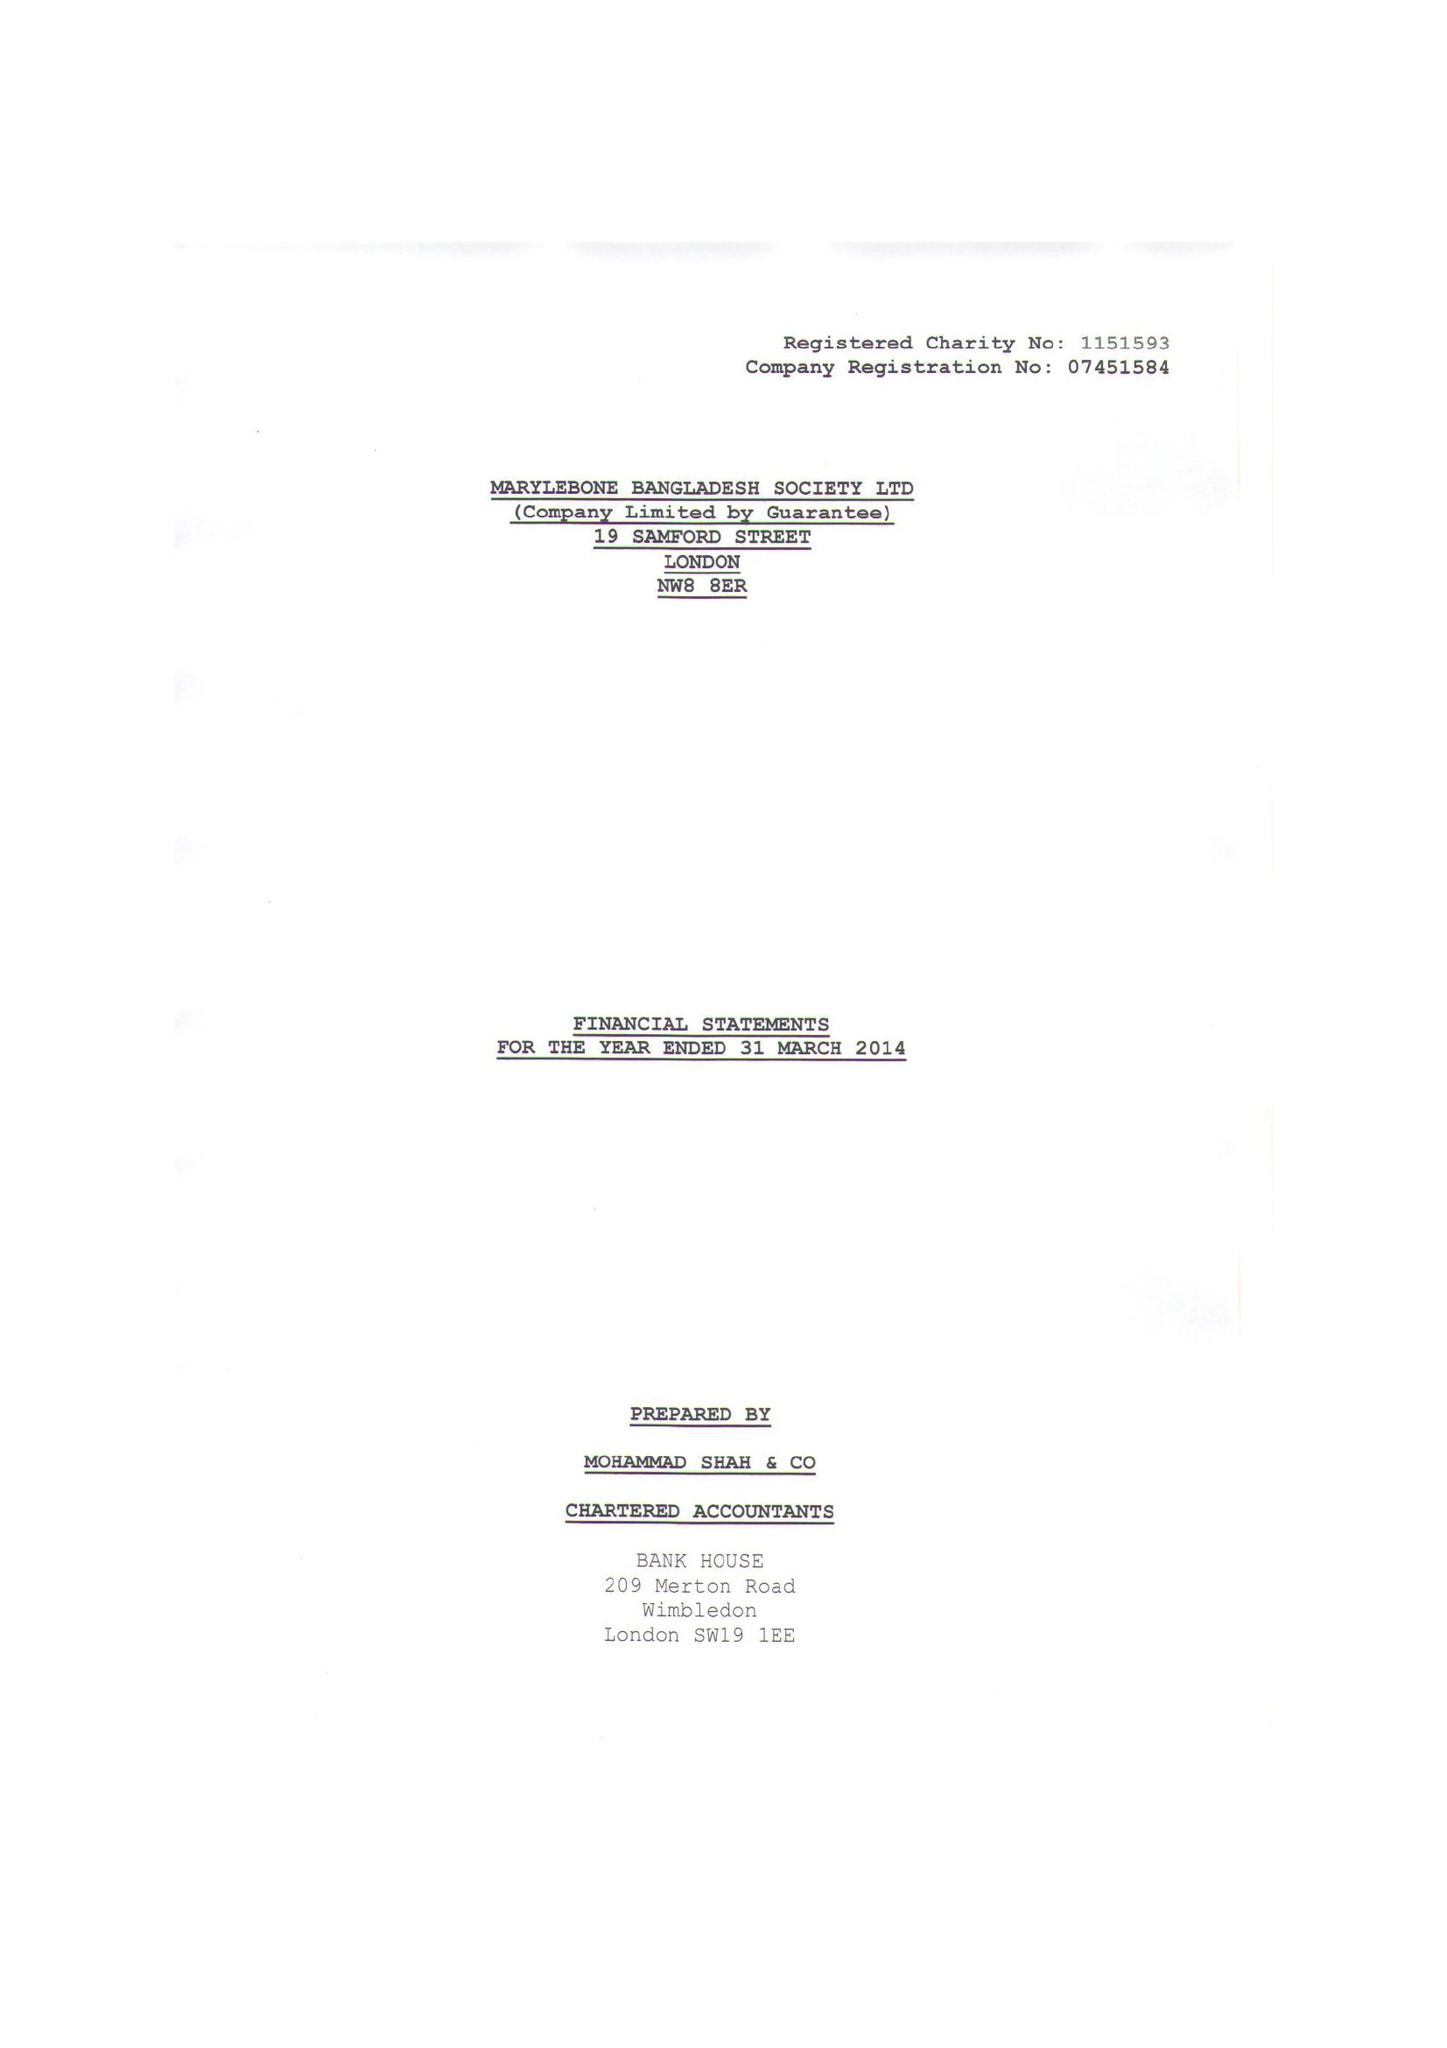What is the value for the spending_annually_in_british_pounds?
Answer the question using a single word or phrase. 194040.00 